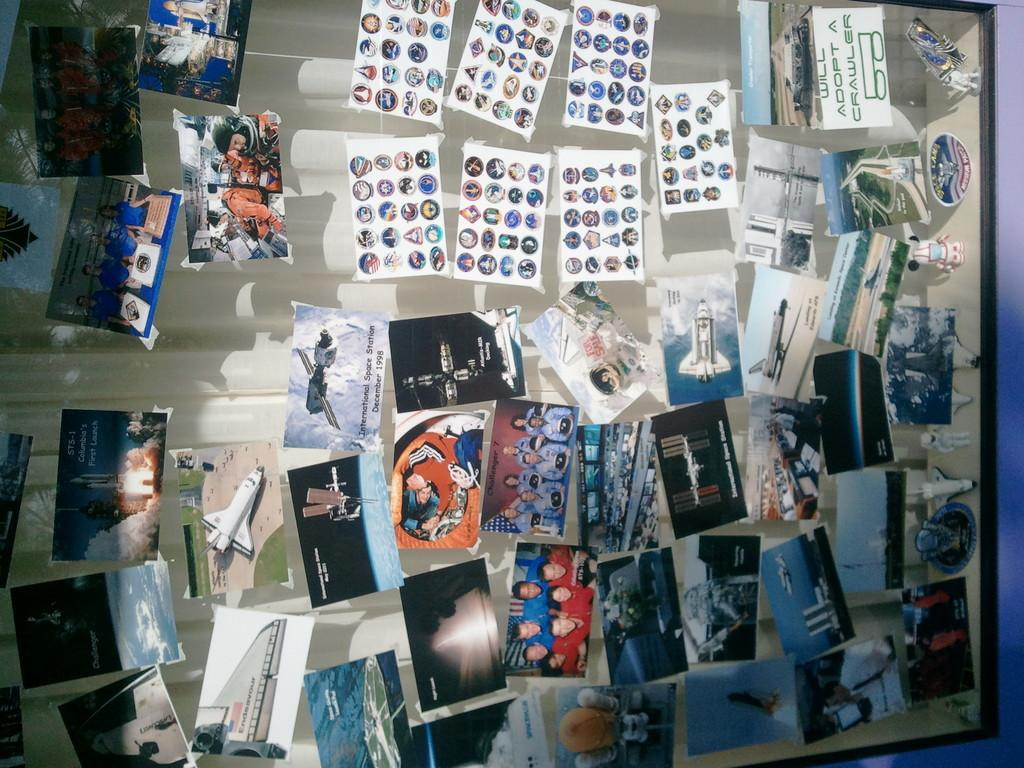What is present in the image? There are photographs in the image. How are the photographs displayed? The photographs are attached to a glass surface. What is the price of the quince in the image? There is no quince present in the image, so it is not possible to determine its price. 